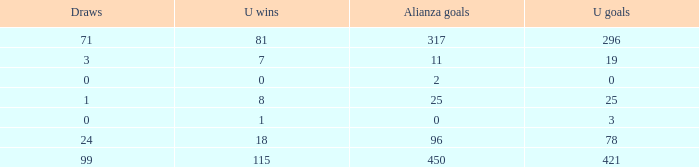What is the minimum u victories, when alianza triumphs is more than 0, when alianza scores is above 25, and when ties is "99"? 115.0. 